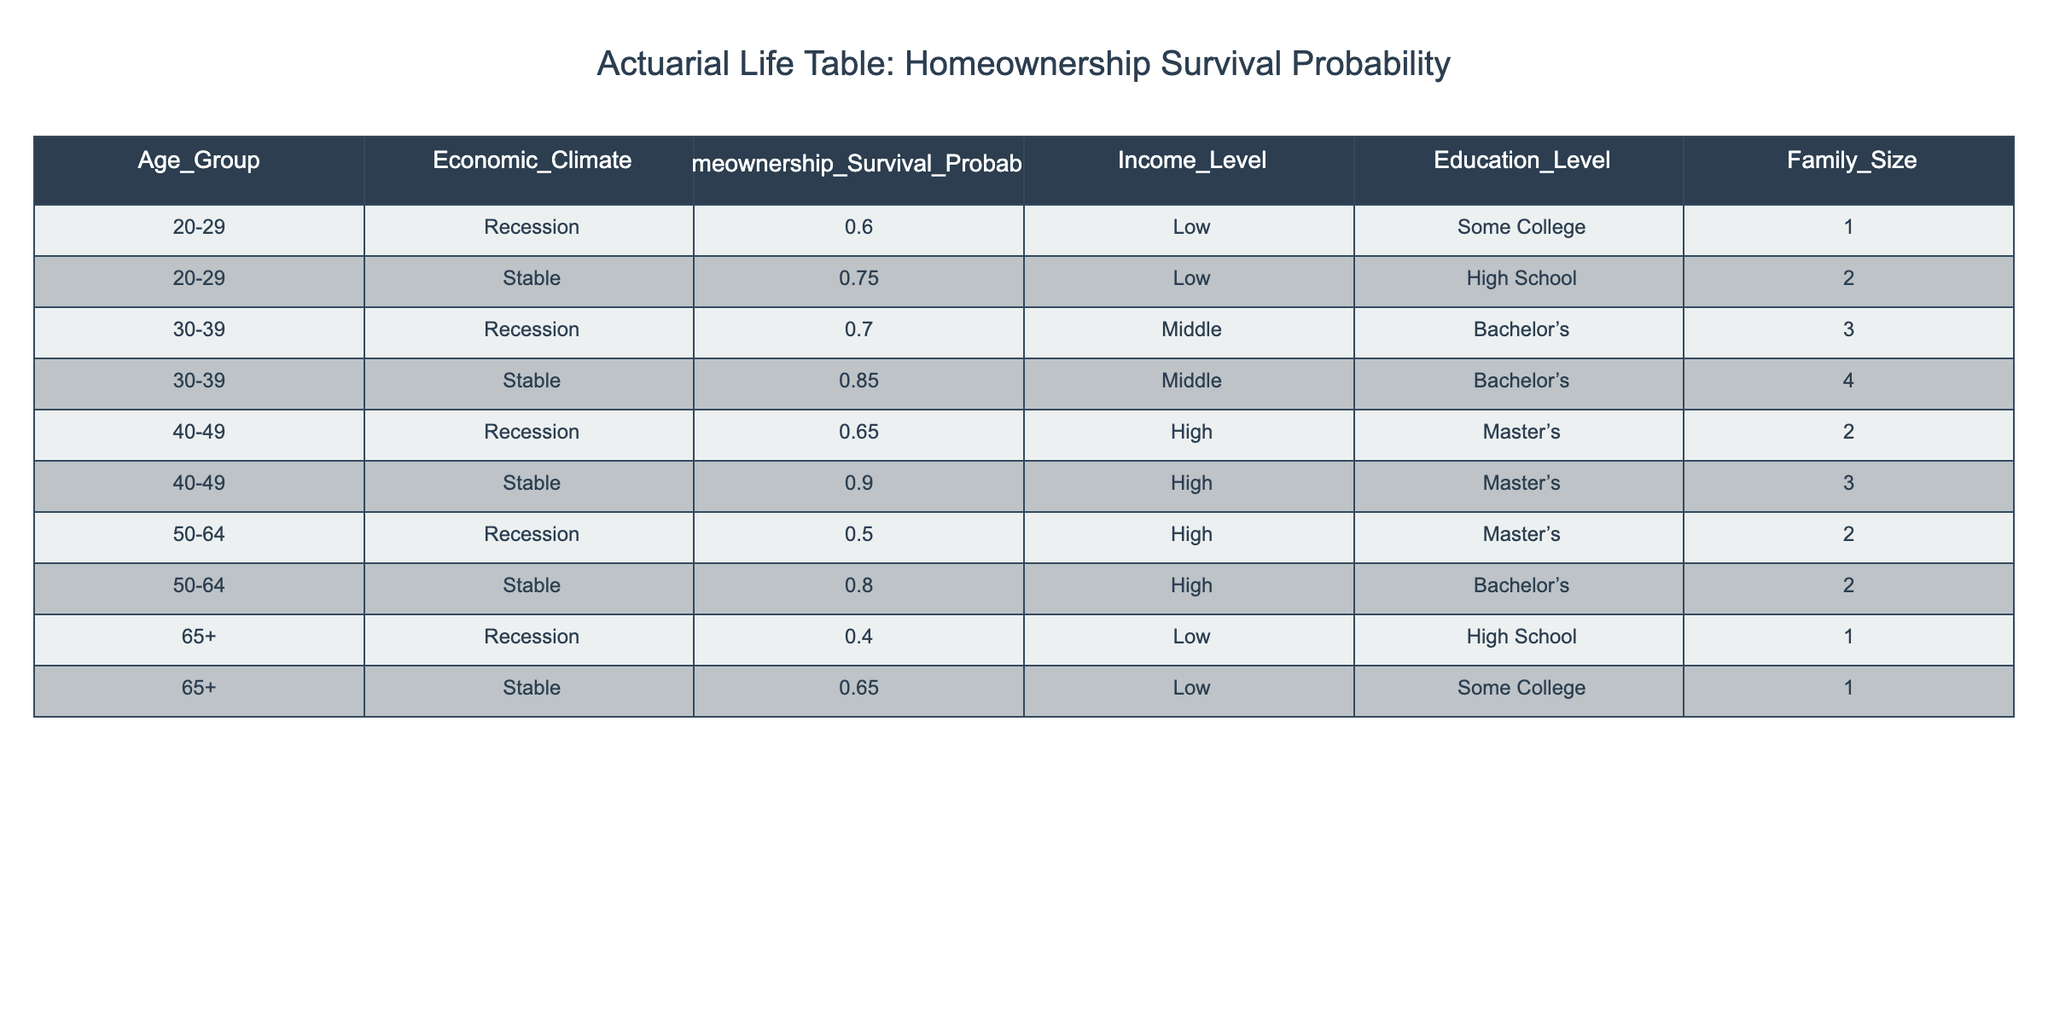What is the Homeownership Survival Probability for individuals aged 30-39 in a Stable economic climate? In the table, we look under the Age_Group column for "30-39" and locate the corresponding row with "Stable" in the Economic_Climate column. The Homeownership Survival Probability for this group is 0.85.
Answer: 0.85 What is the Homeownership Survival Probability for individuals aged 65+ in a Recession? In the table, we find the row with Age_Group "65+" and Economic_Climate "Recession." The Homeownership Survival Probability listed in that row is 0.40.
Answer: 0.40 Is the Homeownership Survival Probability greater for individuals with a Master's degree or those with a Bachelor's degree in a Recession? We look at the rows for Recession with Master's degrees (ages 40-49 and 50-64) and Bachelor's degrees (ages 30-39). The chances for the Master's degree holders are 0.65 (40-49) and 0.50 (50-64) and for the Bachelor's it is 0.70. The average for Master's is (0.65 + 0.50) / 2 = 0.575, while Bachelor's is 0.70. So yes, Bachelor’s holders have a higher survival probability.
Answer: Yes On average, what is the Homeownership Survival Probability for individuals across all age groups in a Stable economic climate? We take the probabilities for the Stable economic climate from each age group: 0.75 (20-29), 0.85 (30-39), 0.90 (40-49), 0.80 (50-64), 0.65 (65+). We sum these: 0.75 + 0.85 + 0.90 + 0.80 + 0.65 = 4.85. There are 5 values, thus the average is 4.85 / 5 = 0.97.
Answer: 0.97 Is it true that family size affects Homeownership Survival Probability in a Stable economic climate? To determine this, we can look at the Survival Probabilities for Stable economic conditions: 0.75 with Family_Size 2, 0.85 with 4, 0.90 with 3, 0.80 with 2, and 0.65 with 1. The values do not show a clear increasing or decreasing pattern with family size, indicating that there is no definitive effect based on these data points.
Answer: No 